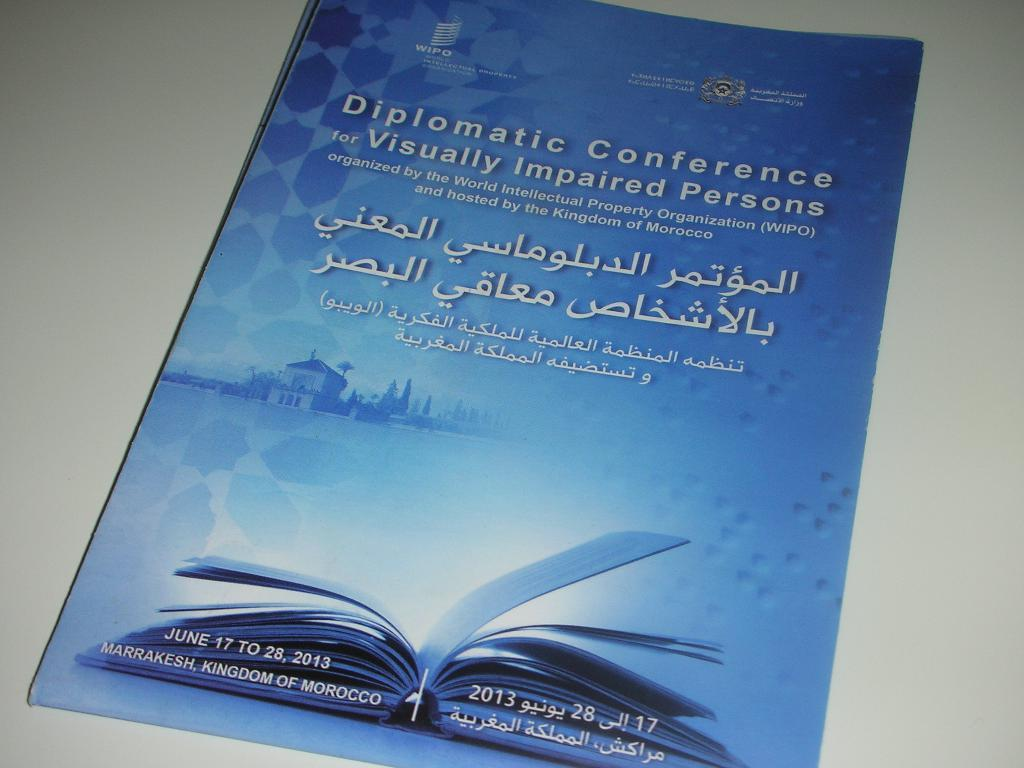<image>
Give a short and clear explanation of the subsequent image. A pamphlet for diplomatic conference for visually impaired persons. 